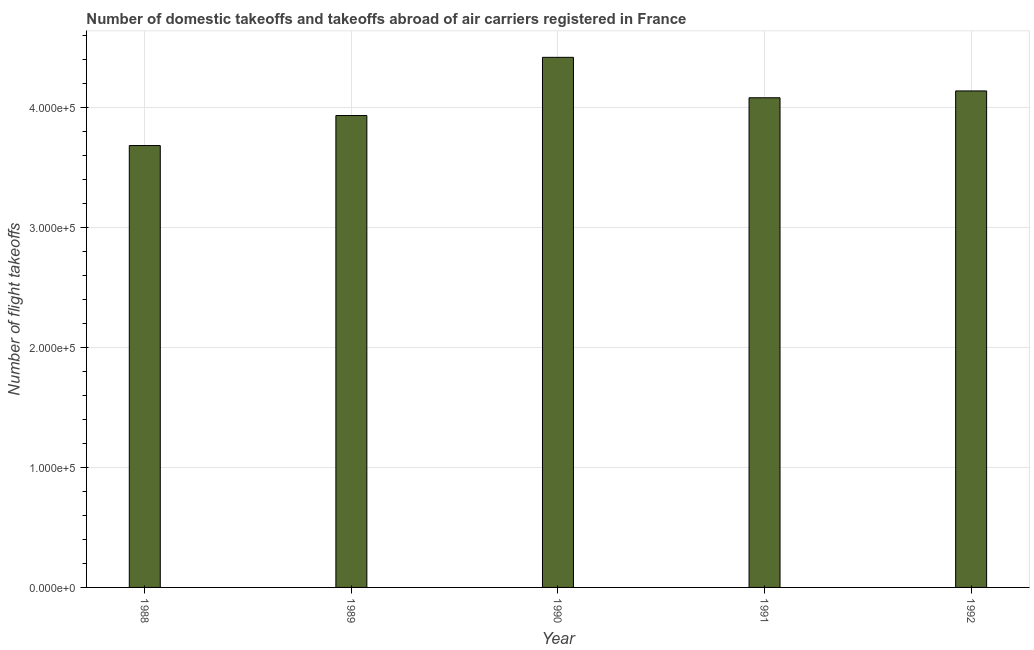Does the graph contain grids?
Offer a terse response. Yes. What is the title of the graph?
Your answer should be compact. Number of domestic takeoffs and takeoffs abroad of air carriers registered in France. What is the label or title of the Y-axis?
Offer a very short reply. Number of flight takeoffs. What is the number of flight takeoffs in 1992?
Your answer should be very brief. 4.14e+05. Across all years, what is the maximum number of flight takeoffs?
Your response must be concise. 4.42e+05. Across all years, what is the minimum number of flight takeoffs?
Offer a very short reply. 3.68e+05. In which year was the number of flight takeoffs minimum?
Your answer should be very brief. 1988. What is the sum of the number of flight takeoffs?
Offer a very short reply. 2.02e+06. What is the difference between the number of flight takeoffs in 1988 and 1991?
Ensure brevity in your answer.  -3.98e+04. What is the average number of flight takeoffs per year?
Your answer should be compact. 4.05e+05. What is the median number of flight takeoffs?
Offer a terse response. 4.08e+05. What is the difference between the highest and the second highest number of flight takeoffs?
Your response must be concise. 2.80e+04. What is the difference between the highest and the lowest number of flight takeoffs?
Provide a short and direct response. 7.35e+04. In how many years, is the number of flight takeoffs greater than the average number of flight takeoffs taken over all years?
Make the answer very short. 3. Are all the bars in the graph horizontal?
Your answer should be compact. No. How many years are there in the graph?
Offer a very short reply. 5. Are the values on the major ticks of Y-axis written in scientific E-notation?
Your answer should be very brief. Yes. What is the Number of flight takeoffs of 1988?
Keep it short and to the point. 3.68e+05. What is the Number of flight takeoffs in 1989?
Your answer should be very brief. 3.93e+05. What is the Number of flight takeoffs of 1990?
Keep it short and to the point. 4.42e+05. What is the Number of flight takeoffs in 1991?
Provide a succinct answer. 4.08e+05. What is the Number of flight takeoffs in 1992?
Your answer should be very brief. 4.14e+05. What is the difference between the Number of flight takeoffs in 1988 and 1989?
Keep it short and to the point. -2.50e+04. What is the difference between the Number of flight takeoffs in 1988 and 1990?
Keep it short and to the point. -7.35e+04. What is the difference between the Number of flight takeoffs in 1988 and 1991?
Provide a succinct answer. -3.98e+04. What is the difference between the Number of flight takeoffs in 1988 and 1992?
Your response must be concise. -4.55e+04. What is the difference between the Number of flight takeoffs in 1989 and 1990?
Keep it short and to the point. -4.85e+04. What is the difference between the Number of flight takeoffs in 1989 and 1991?
Offer a very short reply. -1.48e+04. What is the difference between the Number of flight takeoffs in 1989 and 1992?
Offer a terse response. -2.05e+04. What is the difference between the Number of flight takeoffs in 1990 and 1991?
Make the answer very short. 3.37e+04. What is the difference between the Number of flight takeoffs in 1990 and 1992?
Make the answer very short. 2.80e+04. What is the difference between the Number of flight takeoffs in 1991 and 1992?
Offer a terse response. -5700. What is the ratio of the Number of flight takeoffs in 1988 to that in 1989?
Ensure brevity in your answer.  0.94. What is the ratio of the Number of flight takeoffs in 1988 to that in 1990?
Provide a short and direct response. 0.83. What is the ratio of the Number of flight takeoffs in 1988 to that in 1991?
Your response must be concise. 0.9. What is the ratio of the Number of flight takeoffs in 1988 to that in 1992?
Offer a terse response. 0.89. What is the ratio of the Number of flight takeoffs in 1989 to that in 1990?
Provide a short and direct response. 0.89. What is the ratio of the Number of flight takeoffs in 1989 to that in 1991?
Make the answer very short. 0.96. What is the ratio of the Number of flight takeoffs in 1990 to that in 1991?
Provide a succinct answer. 1.08. What is the ratio of the Number of flight takeoffs in 1990 to that in 1992?
Offer a terse response. 1.07. 